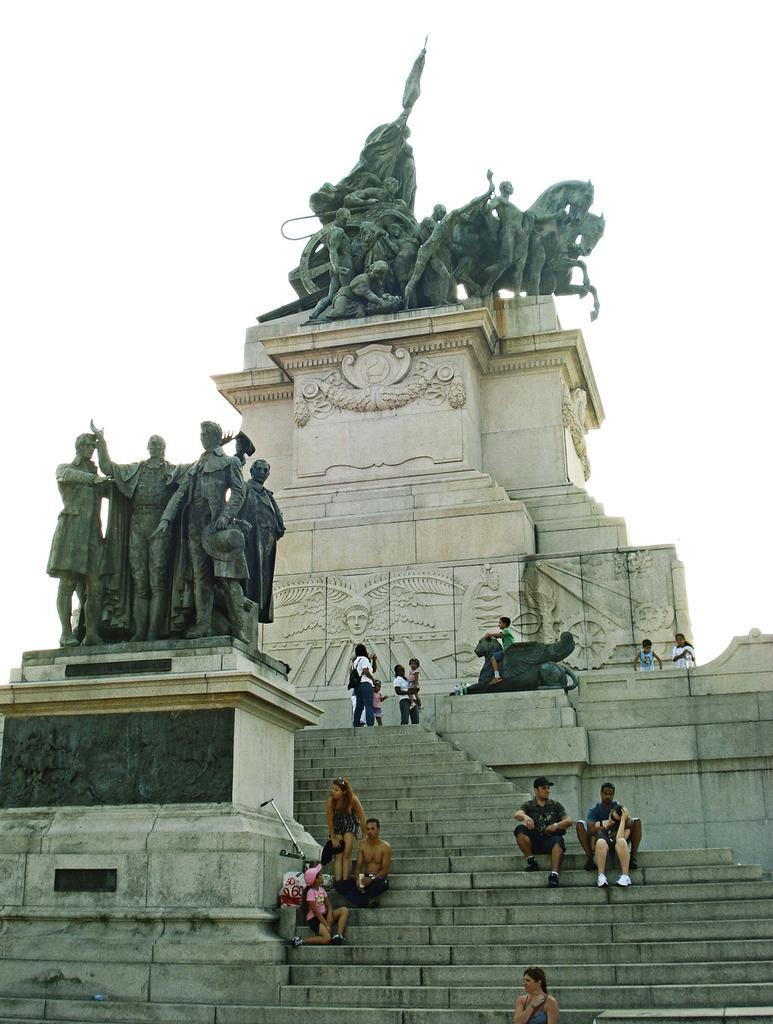How would you summarize this image in a sentence or two? In this image there are group of people standing and sitting on the stairs , there are sculptures of people and horses , and in the background there is sky. 